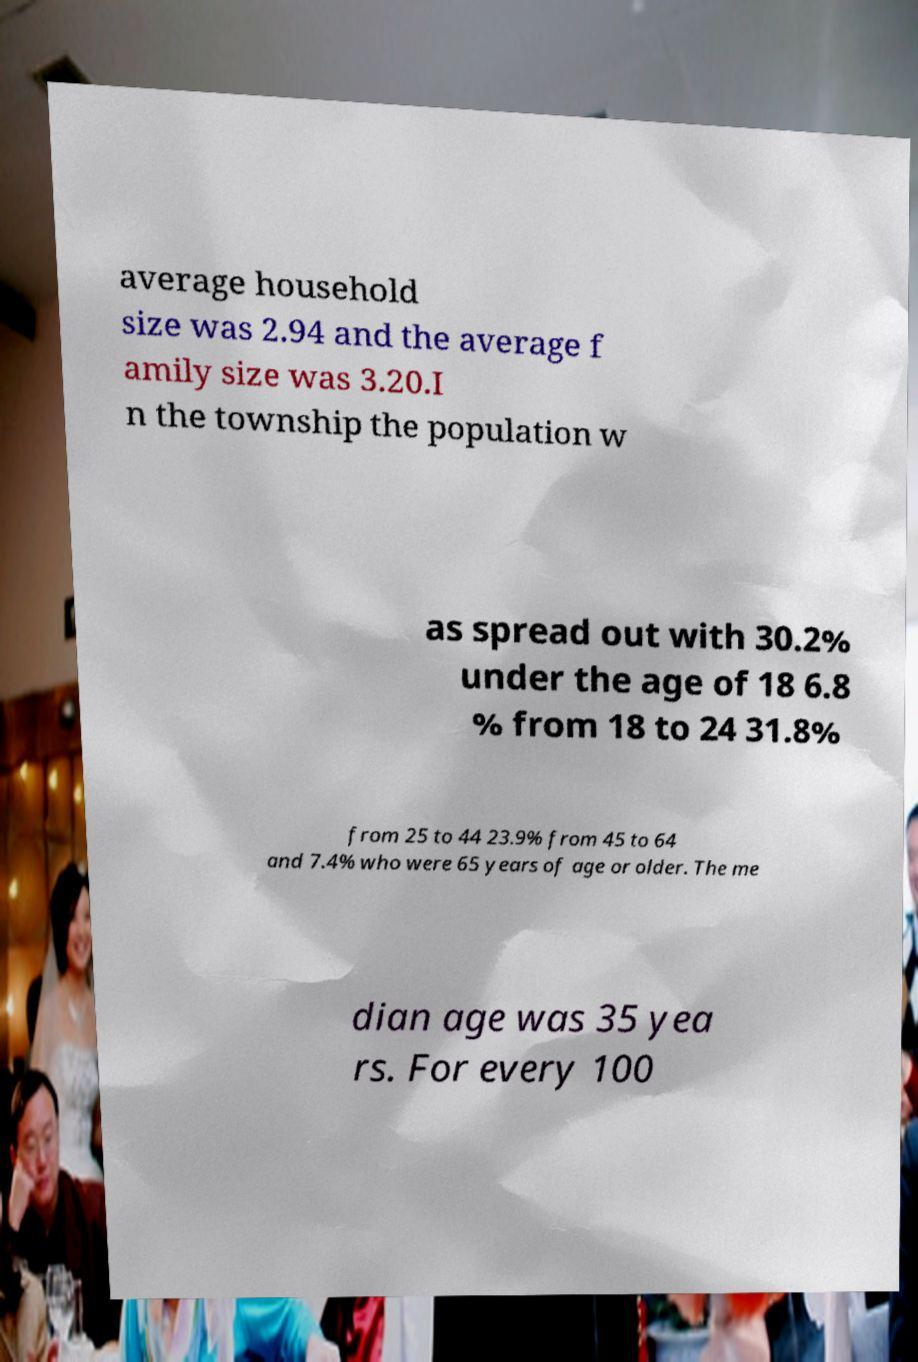Please identify and transcribe the text found in this image. average household size was 2.94 and the average f amily size was 3.20.I n the township the population w as spread out with 30.2% under the age of 18 6.8 % from 18 to 24 31.8% from 25 to 44 23.9% from 45 to 64 and 7.4% who were 65 years of age or older. The me dian age was 35 yea rs. For every 100 